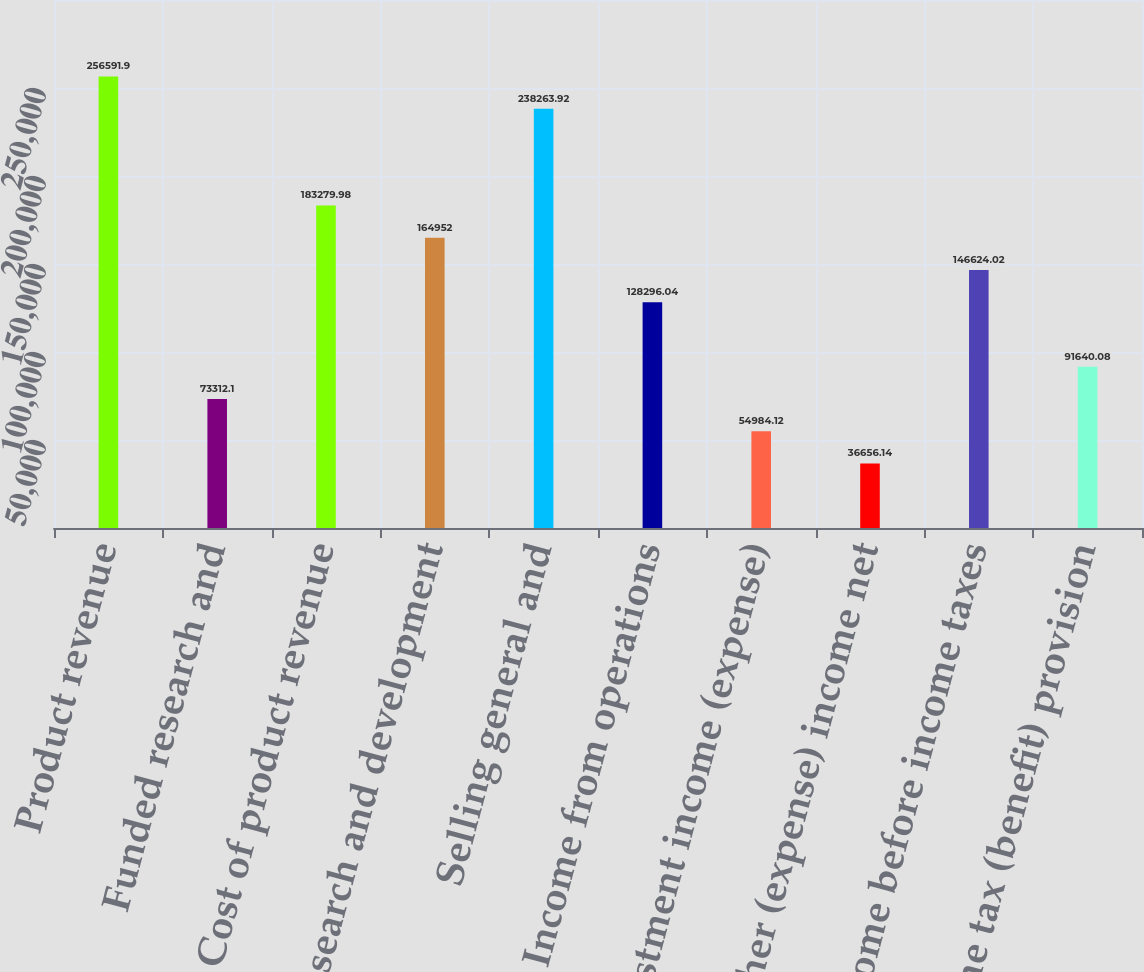Convert chart to OTSL. <chart><loc_0><loc_0><loc_500><loc_500><bar_chart><fcel>Product revenue<fcel>Funded research and<fcel>Cost of product revenue<fcel>Research and development<fcel>Selling general and<fcel>Income from operations<fcel>Investment income (expense)<fcel>Other (expense) income net<fcel>Income before income taxes<fcel>Income tax (benefit) provision<nl><fcel>256592<fcel>73312.1<fcel>183280<fcel>164952<fcel>238264<fcel>128296<fcel>54984.1<fcel>36656.1<fcel>146624<fcel>91640.1<nl></chart> 